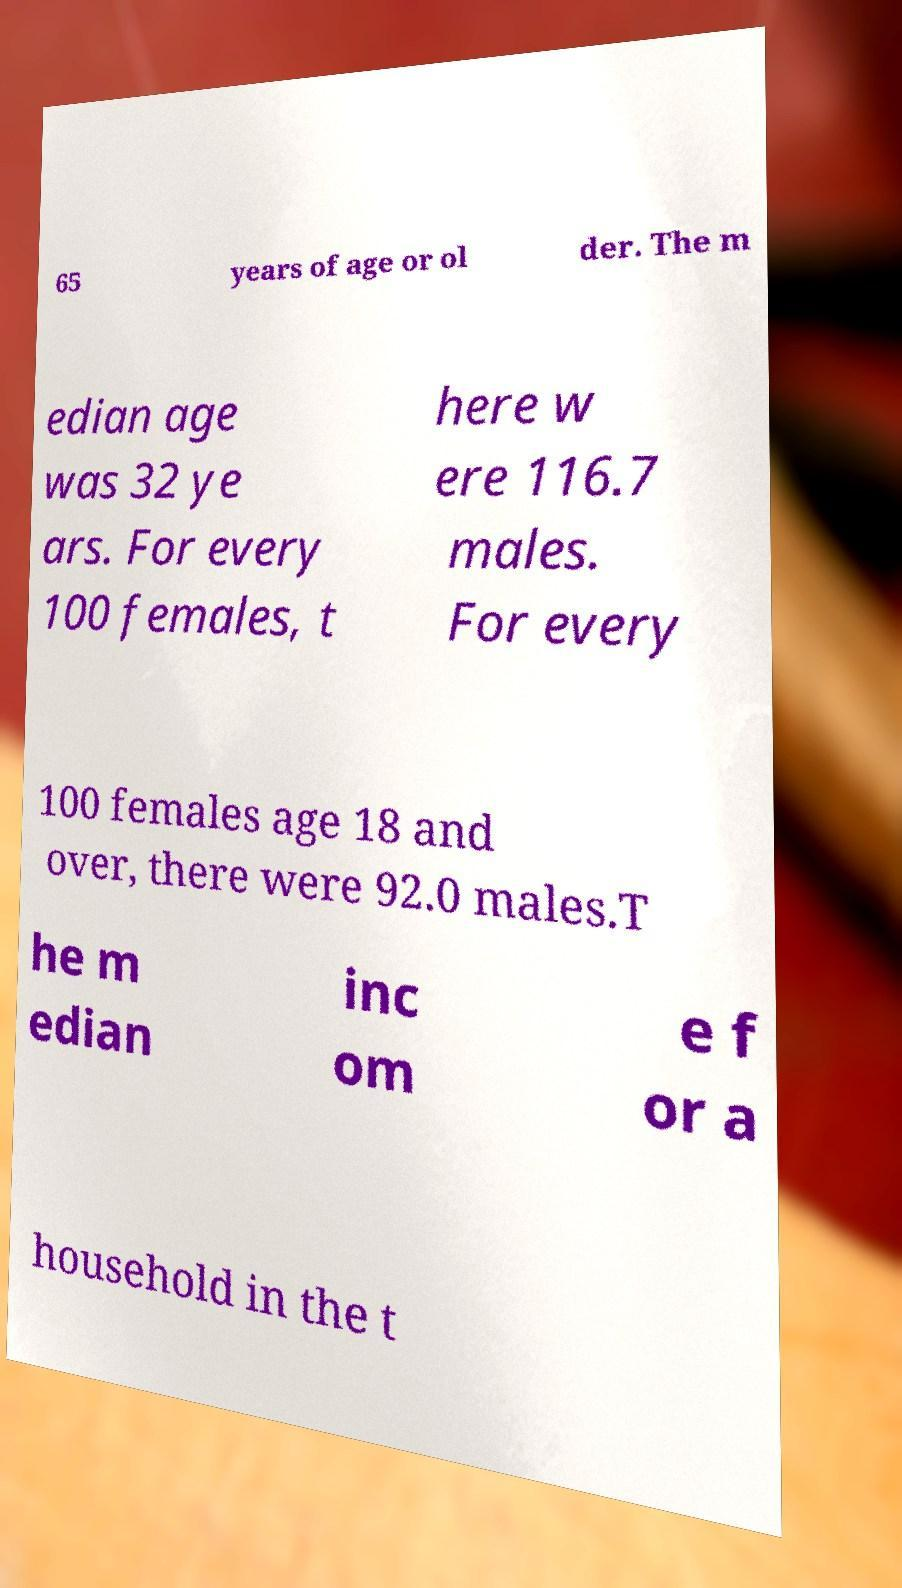Please identify and transcribe the text found in this image. 65 years of age or ol der. The m edian age was 32 ye ars. For every 100 females, t here w ere 116.7 males. For every 100 females age 18 and over, there were 92.0 males.T he m edian inc om e f or a household in the t 